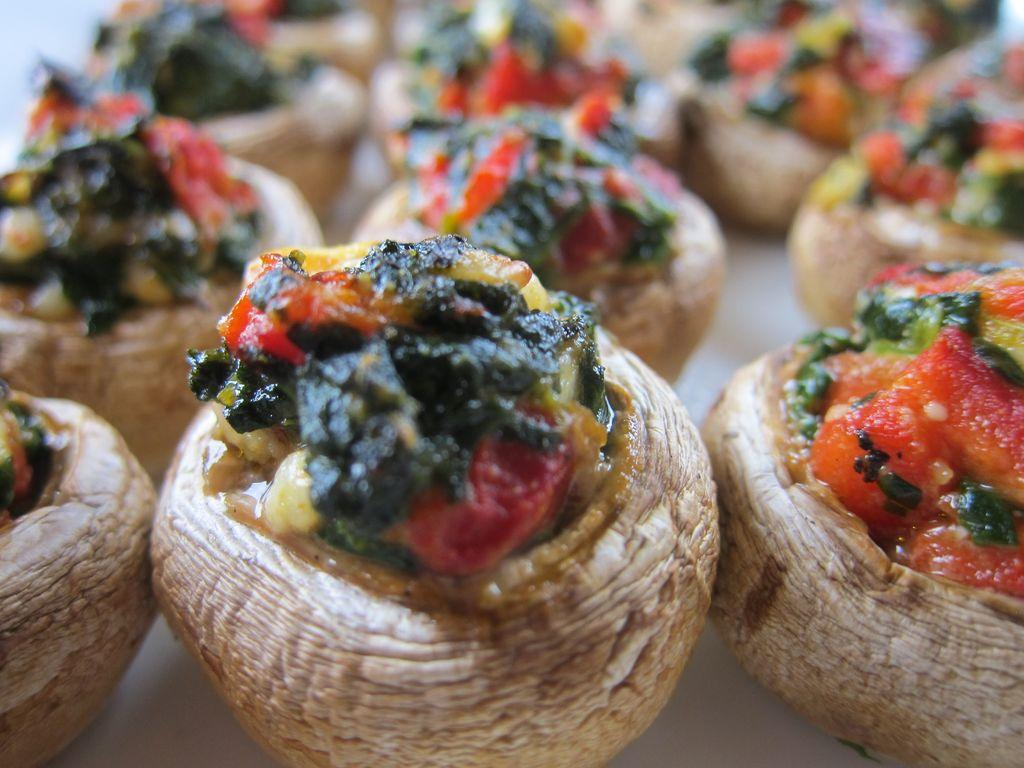What is the main subject of the image? The main subject of the image is a food item. What color is the potato next to the food item in the image? There is no potato present in the image, and therefore no color can be determined for it. 